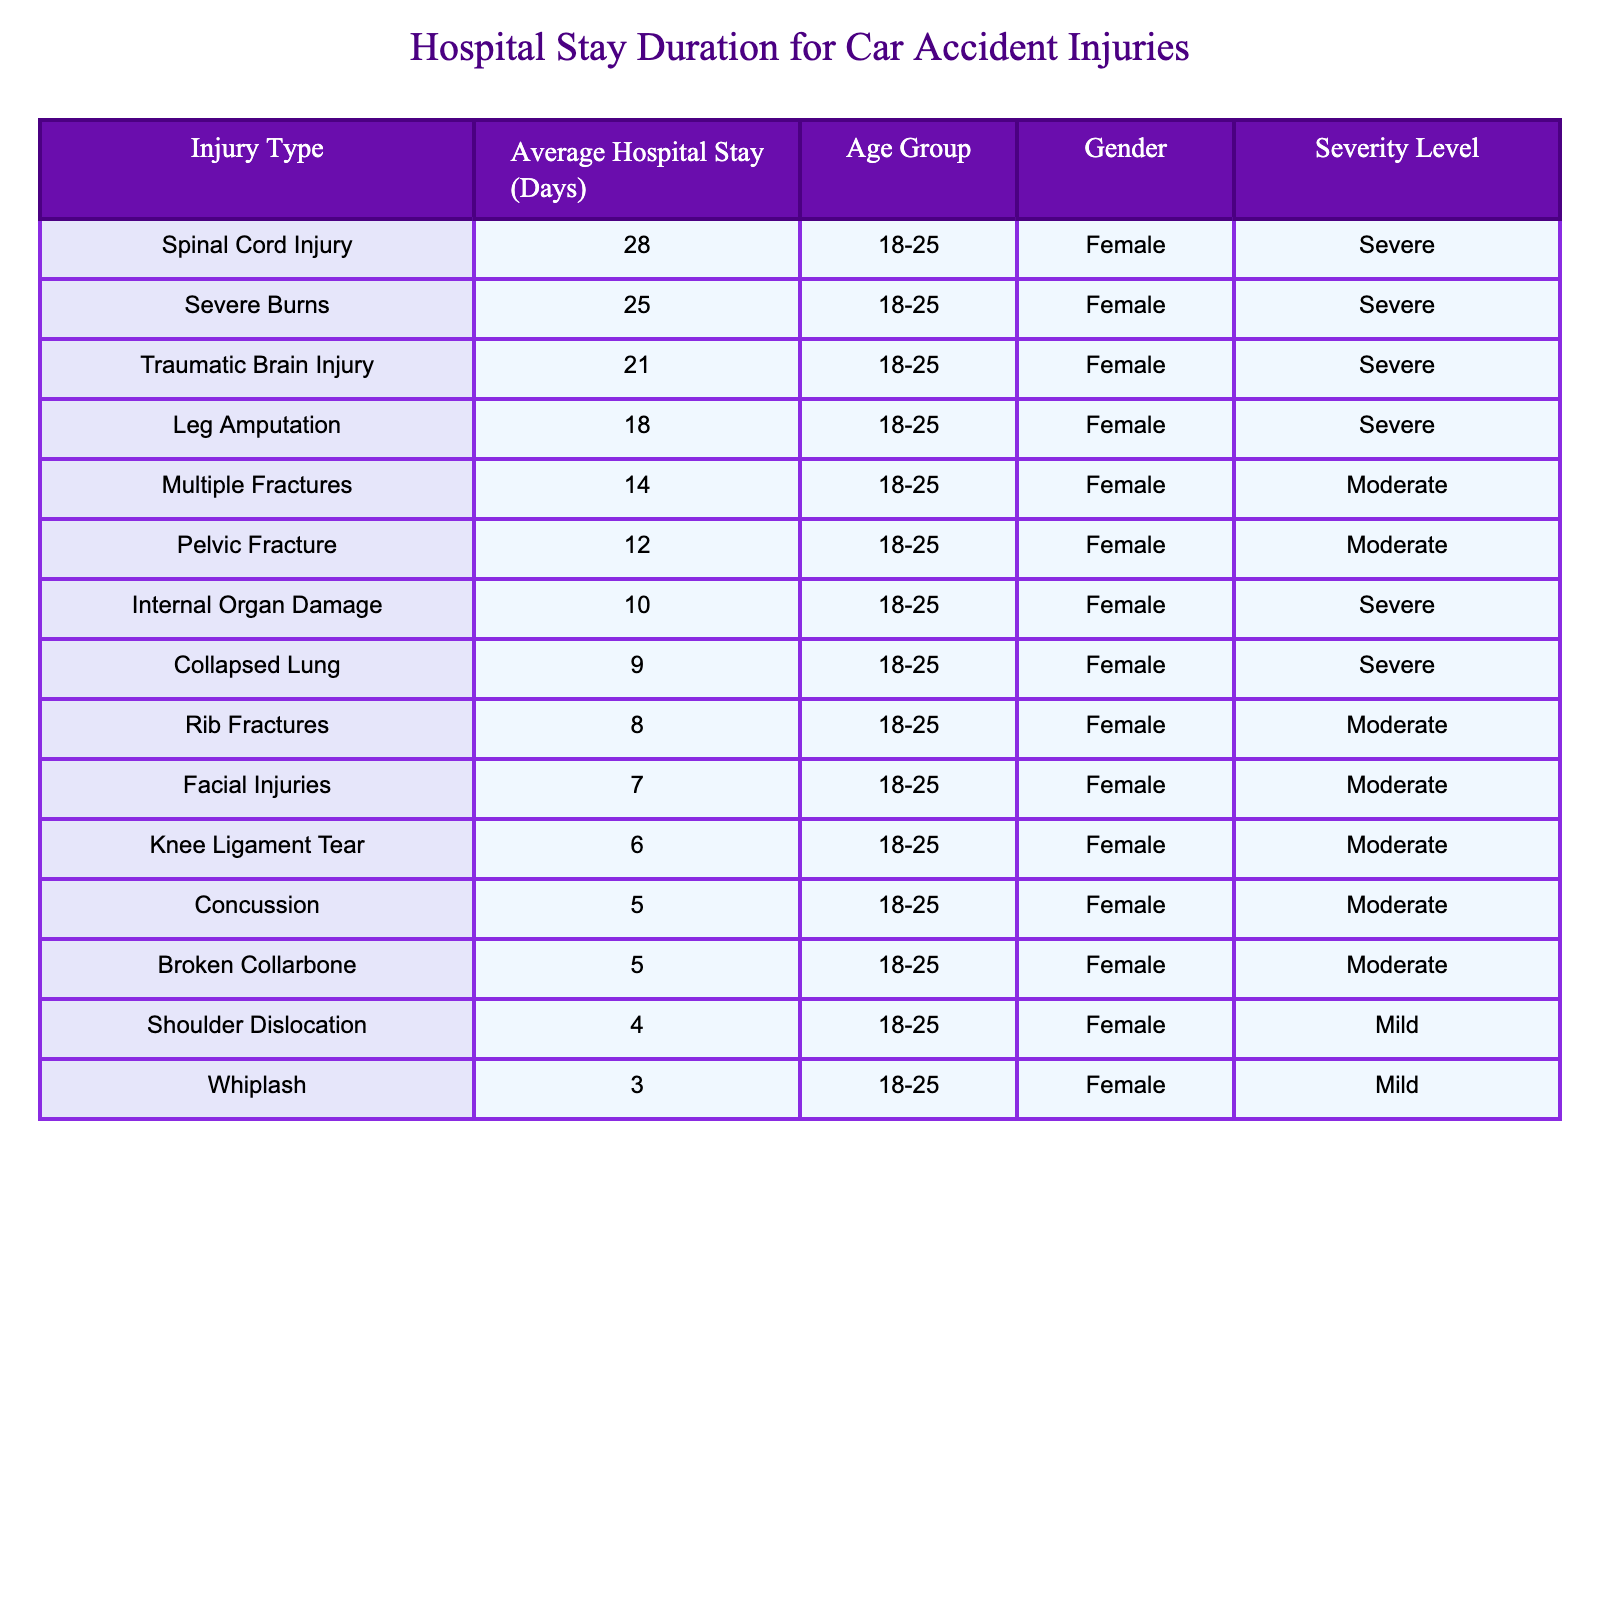What is the average hospital stay for a spinal cord injury? The table shows that the average hospital stay for a spinal cord injury is 28 days.
Answer: 28 days Which injury type has the shortest average hospital stay? According to the table, whiplash has the shortest average hospital stay of 3 days.
Answer: 3 days How many injury types have an average hospital stay of 10 days or less? The table lists two injury types with an average hospital stay of 10 days or less: internal organ damage (10 days) and whiplash (3 days).
Answer: 2 injury types What is the average hospital stay for severe injuries? The severe injuries listed are traumatic brain injury (21 days), spinal cord injury (28 days), internal organ damage (10 days), leg amputation (18 days), severe burns (25 days), and collapsed lung (9 days). Adding these together gives 21 + 28 + 10 + 18 + 25 + 9 = 111 days. There are 6 severe injuries, so the average is 111/6 = 18.5 days.
Answer: 18.5 days Is the average hospital stay for a pelvic fracture greater than that for a rib fracture? The average hospital stay for a pelvic fracture is 12 days, while for a rib fracture it is 8 days. Since 12 is greater than 8, the answer is yes.
Answer: Yes Which injury type has the longest average hospital stay among moderate injuries? The moderate injuries listed are multiple fractures (14 days), concussion (5 days), pelvic fracture (12 days), facial injuries (7 days), rib fractures (8 days), and knee ligament tear (6 days). The longest stay among these is 14 days for multiple fractures.
Answer: 14 days If we combine the hospital stays for all mild injuries, what would that total be? The mild injuries are whiplash (3 days) and shoulder dislocation (4 days). Adding these gives a total of 3 + 4 = 7 days.
Answer: 7 days What percentage of injuries listed have a severity level of severe? There are 12 types of injuries in total listed. The severe injuries are traumatic brain injury, spinal cord injury, internal organ damage, leg amputation, severe burns, and collapsed lung, totaling 6 severe injuries. To find the percentage, (6/12)*100 = 50%.
Answer: 50% Are there more types of injuries categorized as "Severe" than those categorized as "Mild"? There are 6 severe injuries and 2 mild injuries (whiplash and shoulder dislocation). Since 6 is greater than 2, the answer is yes.
Answer: Yes What is the average length of stay for injuries categorized under the "Moderate" severity level? The moderate injuries with their stays are multiple fractures (14 days), concussion (5 days), pelvic fracture (12 days), facial injuries (7 days), rib fractures (8 days), and knee ligament tear (6 days). Adding gives 14 + 5 + 12 + 7 + 8 + 6 = 52 days. There are 6 moderate injuries, so the average is 52/6 ≈ 8.67 days.
Answer: 8.67 days 